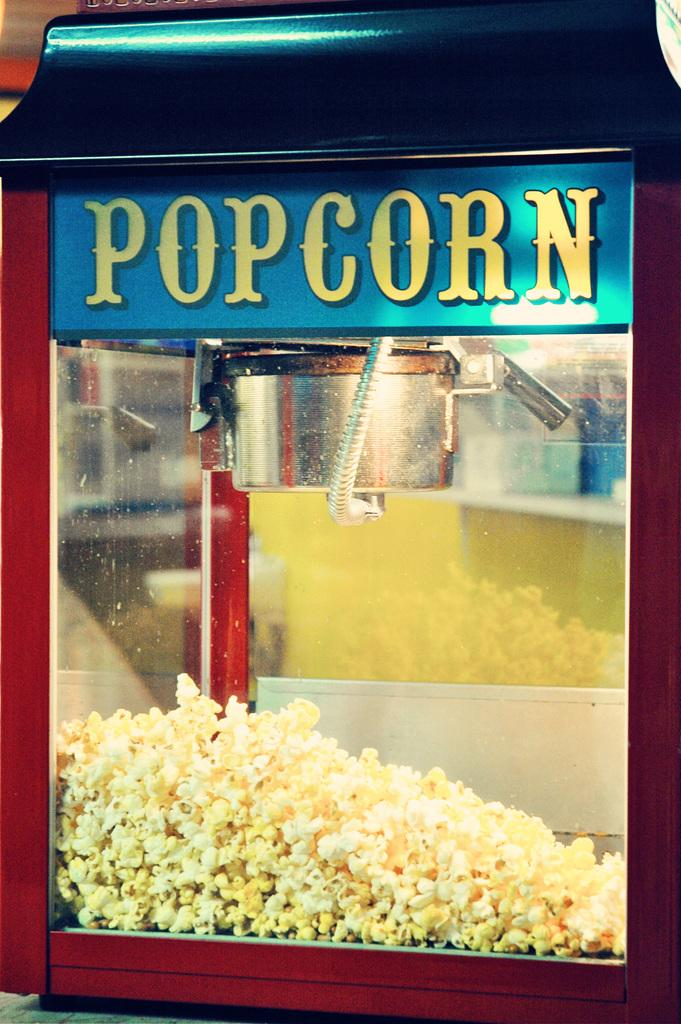<image>
Describe the image concisely. a red trimmed glass box labeled 'popcorn' in yellow 